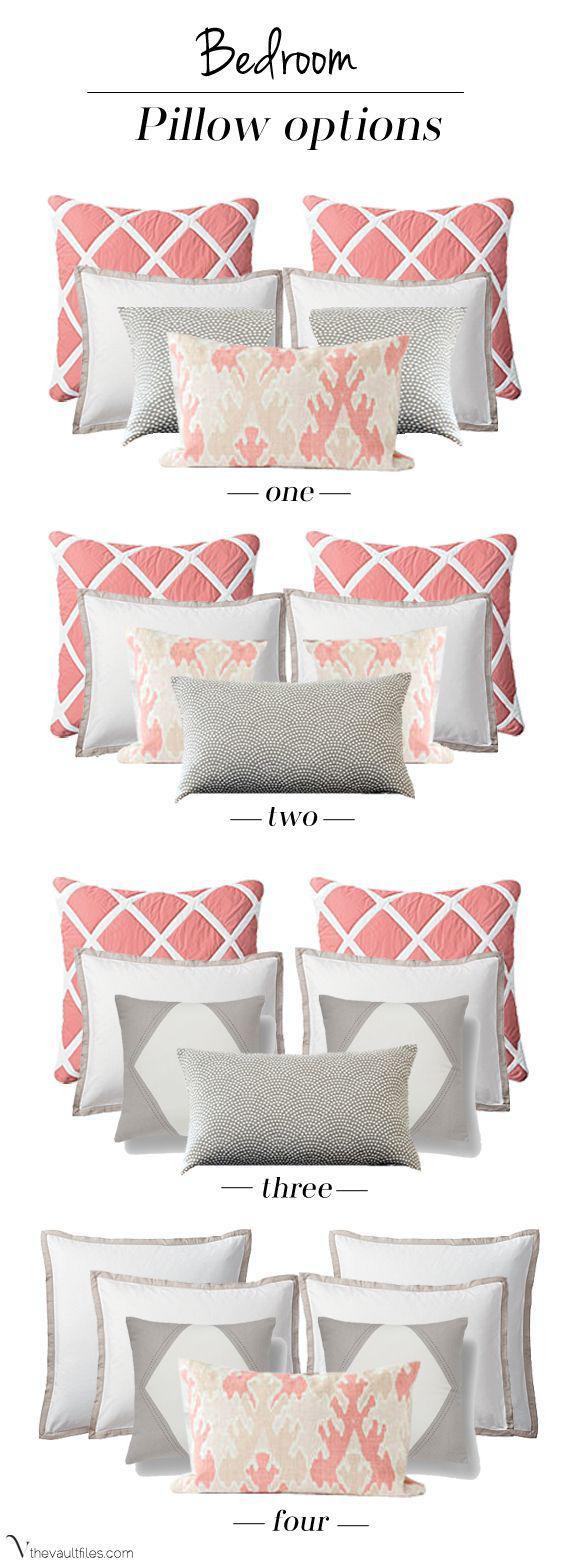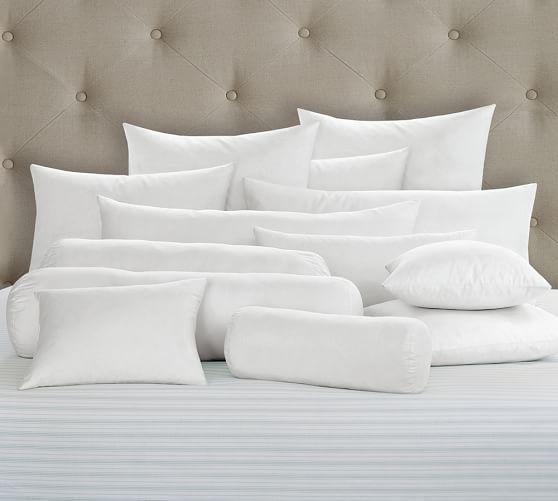The first image is the image on the left, the second image is the image on the right. Considering the images on both sides, is "White pillows are arranged in front of an upholstered headboard in at least one image." valid? Answer yes or no. Yes. 